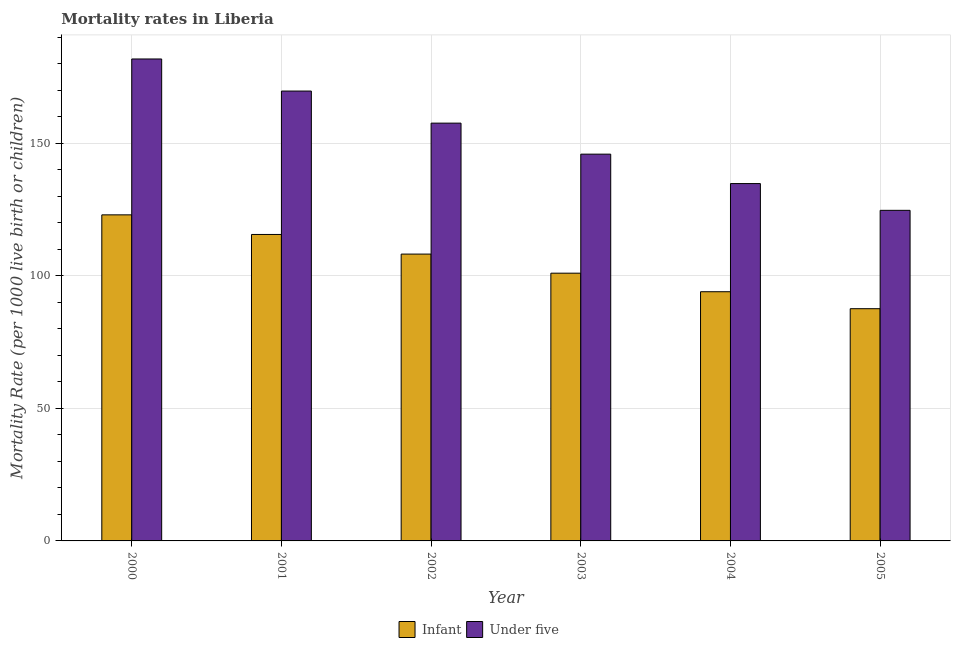How many different coloured bars are there?
Your answer should be very brief. 2. How many groups of bars are there?
Provide a succinct answer. 6. How many bars are there on the 1st tick from the right?
Offer a terse response. 2. What is the label of the 4th group of bars from the left?
Provide a short and direct response. 2003. In how many cases, is the number of bars for a given year not equal to the number of legend labels?
Keep it short and to the point. 0. What is the under-5 mortality rate in 2004?
Keep it short and to the point. 134.8. Across all years, what is the maximum infant mortality rate?
Make the answer very short. 123. Across all years, what is the minimum infant mortality rate?
Make the answer very short. 87.6. In which year was the under-5 mortality rate maximum?
Make the answer very short. 2000. What is the total under-5 mortality rate in the graph?
Provide a succinct answer. 914.5. What is the difference between the under-5 mortality rate in 2002 and that in 2005?
Provide a short and direct response. 32.9. What is the difference between the under-5 mortality rate in 2003 and the infant mortality rate in 2001?
Give a very brief answer. -23.8. What is the average infant mortality rate per year?
Offer a terse response. 104.9. In the year 2001, what is the difference between the under-5 mortality rate and infant mortality rate?
Ensure brevity in your answer.  0. What is the ratio of the under-5 mortality rate in 2000 to that in 2001?
Make the answer very short. 1.07. Is the difference between the infant mortality rate in 2000 and 2003 greater than the difference between the under-5 mortality rate in 2000 and 2003?
Your answer should be very brief. No. What is the difference between the highest and the second highest infant mortality rate?
Your answer should be very brief. 7.4. What is the difference between the highest and the lowest infant mortality rate?
Your response must be concise. 35.4. In how many years, is the under-5 mortality rate greater than the average under-5 mortality rate taken over all years?
Provide a succinct answer. 3. What does the 1st bar from the left in 2002 represents?
Give a very brief answer. Infant. What does the 2nd bar from the right in 2004 represents?
Provide a short and direct response. Infant. How many bars are there?
Ensure brevity in your answer.  12. Are all the bars in the graph horizontal?
Keep it short and to the point. No. How many years are there in the graph?
Provide a short and direct response. 6. What is the difference between two consecutive major ticks on the Y-axis?
Your response must be concise. 50. Are the values on the major ticks of Y-axis written in scientific E-notation?
Your answer should be very brief. No. Does the graph contain any zero values?
Your response must be concise. No. Does the graph contain grids?
Provide a short and direct response. Yes. Where does the legend appear in the graph?
Keep it short and to the point. Bottom center. How are the legend labels stacked?
Keep it short and to the point. Horizontal. What is the title of the graph?
Keep it short and to the point. Mortality rates in Liberia. Does "Commercial bank branches" appear as one of the legend labels in the graph?
Your response must be concise. No. What is the label or title of the Y-axis?
Keep it short and to the point. Mortality Rate (per 1000 live birth or children). What is the Mortality Rate (per 1000 live birth or children) in Infant in 2000?
Ensure brevity in your answer.  123. What is the Mortality Rate (per 1000 live birth or children) of Under five in 2000?
Provide a short and direct response. 181.8. What is the Mortality Rate (per 1000 live birth or children) of Infant in 2001?
Provide a short and direct response. 115.6. What is the Mortality Rate (per 1000 live birth or children) in Under five in 2001?
Offer a very short reply. 169.7. What is the Mortality Rate (per 1000 live birth or children) of Infant in 2002?
Offer a terse response. 108.2. What is the Mortality Rate (per 1000 live birth or children) of Under five in 2002?
Offer a terse response. 157.6. What is the Mortality Rate (per 1000 live birth or children) in Infant in 2003?
Offer a very short reply. 101. What is the Mortality Rate (per 1000 live birth or children) in Under five in 2003?
Offer a terse response. 145.9. What is the Mortality Rate (per 1000 live birth or children) in Infant in 2004?
Offer a very short reply. 94. What is the Mortality Rate (per 1000 live birth or children) in Under five in 2004?
Give a very brief answer. 134.8. What is the Mortality Rate (per 1000 live birth or children) of Infant in 2005?
Provide a short and direct response. 87.6. What is the Mortality Rate (per 1000 live birth or children) in Under five in 2005?
Make the answer very short. 124.7. Across all years, what is the maximum Mortality Rate (per 1000 live birth or children) in Infant?
Your response must be concise. 123. Across all years, what is the maximum Mortality Rate (per 1000 live birth or children) of Under five?
Your answer should be very brief. 181.8. Across all years, what is the minimum Mortality Rate (per 1000 live birth or children) in Infant?
Offer a very short reply. 87.6. Across all years, what is the minimum Mortality Rate (per 1000 live birth or children) in Under five?
Offer a very short reply. 124.7. What is the total Mortality Rate (per 1000 live birth or children) in Infant in the graph?
Offer a terse response. 629.4. What is the total Mortality Rate (per 1000 live birth or children) of Under five in the graph?
Give a very brief answer. 914.5. What is the difference between the Mortality Rate (per 1000 live birth or children) in Infant in 2000 and that in 2001?
Offer a very short reply. 7.4. What is the difference between the Mortality Rate (per 1000 live birth or children) in Under five in 2000 and that in 2001?
Provide a short and direct response. 12.1. What is the difference between the Mortality Rate (per 1000 live birth or children) in Under five in 2000 and that in 2002?
Your answer should be compact. 24.2. What is the difference between the Mortality Rate (per 1000 live birth or children) of Under five in 2000 and that in 2003?
Your answer should be compact. 35.9. What is the difference between the Mortality Rate (per 1000 live birth or children) in Infant in 2000 and that in 2004?
Your answer should be very brief. 29. What is the difference between the Mortality Rate (per 1000 live birth or children) of Under five in 2000 and that in 2004?
Your response must be concise. 47. What is the difference between the Mortality Rate (per 1000 live birth or children) in Infant in 2000 and that in 2005?
Make the answer very short. 35.4. What is the difference between the Mortality Rate (per 1000 live birth or children) in Under five in 2000 and that in 2005?
Your response must be concise. 57.1. What is the difference between the Mortality Rate (per 1000 live birth or children) in Infant in 2001 and that in 2002?
Your answer should be very brief. 7.4. What is the difference between the Mortality Rate (per 1000 live birth or children) of Under five in 2001 and that in 2002?
Your answer should be very brief. 12.1. What is the difference between the Mortality Rate (per 1000 live birth or children) of Under five in 2001 and that in 2003?
Ensure brevity in your answer.  23.8. What is the difference between the Mortality Rate (per 1000 live birth or children) in Infant in 2001 and that in 2004?
Keep it short and to the point. 21.6. What is the difference between the Mortality Rate (per 1000 live birth or children) of Under five in 2001 and that in 2004?
Provide a succinct answer. 34.9. What is the difference between the Mortality Rate (per 1000 live birth or children) of Under five in 2001 and that in 2005?
Offer a very short reply. 45. What is the difference between the Mortality Rate (per 1000 live birth or children) in Infant in 2002 and that in 2003?
Your response must be concise. 7.2. What is the difference between the Mortality Rate (per 1000 live birth or children) of Under five in 2002 and that in 2004?
Offer a terse response. 22.8. What is the difference between the Mortality Rate (per 1000 live birth or children) of Infant in 2002 and that in 2005?
Your answer should be very brief. 20.6. What is the difference between the Mortality Rate (per 1000 live birth or children) in Under five in 2002 and that in 2005?
Ensure brevity in your answer.  32.9. What is the difference between the Mortality Rate (per 1000 live birth or children) of Infant in 2003 and that in 2004?
Your answer should be compact. 7. What is the difference between the Mortality Rate (per 1000 live birth or children) of Under five in 2003 and that in 2004?
Give a very brief answer. 11.1. What is the difference between the Mortality Rate (per 1000 live birth or children) of Under five in 2003 and that in 2005?
Your answer should be compact. 21.2. What is the difference between the Mortality Rate (per 1000 live birth or children) of Infant in 2000 and the Mortality Rate (per 1000 live birth or children) of Under five in 2001?
Make the answer very short. -46.7. What is the difference between the Mortality Rate (per 1000 live birth or children) in Infant in 2000 and the Mortality Rate (per 1000 live birth or children) in Under five in 2002?
Your answer should be compact. -34.6. What is the difference between the Mortality Rate (per 1000 live birth or children) in Infant in 2000 and the Mortality Rate (per 1000 live birth or children) in Under five in 2003?
Provide a short and direct response. -22.9. What is the difference between the Mortality Rate (per 1000 live birth or children) of Infant in 2000 and the Mortality Rate (per 1000 live birth or children) of Under five in 2005?
Your answer should be compact. -1.7. What is the difference between the Mortality Rate (per 1000 live birth or children) in Infant in 2001 and the Mortality Rate (per 1000 live birth or children) in Under five in 2002?
Ensure brevity in your answer.  -42. What is the difference between the Mortality Rate (per 1000 live birth or children) of Infant in 2001 and the Mortality Rate (per 1000 live birth or children) of Under five in 2003?
Keep it short and to the point. -30.3. What is the difference between the Mortality Rate (per 1000 live birth or children) in Infant in 2001 and the Mortality Rate (per 1000 live birth or children) in Under five in 2004?
Your answer should be compact. -19.2. What is the difference between the Mortality Rate (per 1000 live birth or children) of Infant in 2002 and the Mortality Rate (per 1000 live birth or children) of Under five in 2003?
Offer a terse response. -37.7. What is the difference between the Mortality Rate (per 1000 live birth or children) in Infant in 2002 and the Mortality Rate (per 1000 live birth or children) in Under five in 2004?
Provide a succinct answer. -26.6. What is the difference between the Mortality Rate (per 1000 live birth or children) in Infant in 2002 and the Mortality Rate (per 1000 live birth or children) in Under five in 2005?
Provide a succinct answer. -16.5. What is the difference between the Mortality Rate (per 1000 live birth or children) in Infant in 2003 and the Mortality Rate (per 1000 live birth or children) in Under five in 2004?
Keep it short and to the point. -33.8. What is the difference between the Mortality Rate (per 1000 live birth or children) of Infant in 2003 and the Mortality Rate (per 1000 live birth or children) of Under five in 2005?
Your answer should be very brief. -23.7. What is the difference between the Mortality Rate (per 1000 live birth or children) in Infant in 2004 and the Mortality Rate (per 1000 live birth or children) in Under five in 2005?
Offer a terse response. -30.7. What is the average Mortality Rate (per 1000 live birth or children) in Infant per year?
Give a very brief answer. 104.9. What is the average Mortality Rate (per 1000 live birth or children) of Under five per year?
Offer a terse response. 152.42. In the year 2000, what is the difference between the Mortality Rate (per 1000 live birth or children) in Infant and Mortality Rate (per 1000 live birth or children) in Under five?
Provide a short and direct response. -58.8. In the year 2001, what is the difference between the Mortality Rate (per 1000 live birth or children) in Infant and Mortality Rate (per 1000 live birth or children) in Under five?
Keep it short and to the point. -54.1. In the year 2002, what is the difference between the Mortality Rate (per 1000 live birth or children) in Infant and Mortality Rate (per 1000 live birth or children) in Under five?
Offer a very short reply. -49.4. In the year 2003, what is the difference between the Mortality Rate (per 1000 live birth or children) in Infant and Mortality Rate (per 1000 live birth or children) in Under five?
Ensure brevity in your answer.  -44.9. In the year 2004, what is the difference between the Mortality Rate (per 1000 live birth or children) of Infant and Mortality Rate (per 1000 live birth or children) of Under five?
Make the answer very short. -40.8. In the year 2005, what is the difference between the Mortality Rate (per 1000 live birth or children) in Infant and Mortality Rate (per 1000 live birth or children) in Under five?
Your answer should be compact. -37.1. What is the ratio of the Mortality Rate (per 1000 live birth or children) in Infant in 2000 to that in 2001?
Give a very brief answer. 1.06. What is the ratio of the Mortality Rate (per 1000 live birth or children) of Under five in 2000 to that in 2001?
Your answer should be very brief. 1.07. What is the ratio of the Mortality Rate (per 1000 live birth or children) in Infant in 2000 to that in 2002?
Keep it short and to the point. 1.14. What is the ratio of the Mortality Rate (per 1000 live birth or children) of Under five in 2000 to that in 2002?
Make the answer very short. 1.15. What is the ratio of the Mortality Rate (per 1000 live birth or children) of Infant in 2000 to that in 2003?
Your response must be concise. 1.22. What is the ratio of the Mortality Rate (per 1000 live birth or children) of Under five in 2000 to that in 2003?
Provide a succinct answer. 1.25. What is the ratio of the Mortality Rate (per 1000 live birth or children) of Infant in 2000 to that in 2004?
Keep it short and to the point. 1.31. What is the ratio of the Mortality Rate (per 1000 live birth or children) in Under five in 2000 to that in 2004?
Keep it short and to the point. 1.35. What is the ratio of the Mortality Rate (per 1000 live birth or children) of Infant in 2000 to that in 2005?
Provide a succinct answer. 1.4. What is the ratio of the Mortality Rate (per 1000 live birth or children) of Under five in 2000 to that in 2005?
Your answer should be very brief. 1.46. What is the ratio of the Mortality Rate (per 1000 live birth or children) in Infant in 2001 to that in 2002?
Provide a short and direct response. 1.07. What is the ratio of the Mortality Rate (per 1000 live birth or children) of Under five in 2001 to that in 2002?
Provide a succinct answer. 1.08. What is the ratio of the Mortality Rate (per 1000 live birth or children) in Infant in 2001 to that in 2003?
Your answer should be very brief. 1.14. What is the ratio of the Mortality Rate (per 1000 live birth or children) in Under five in 2001 to that in 2003?
Offer a terse response. 1.16. What is the ratio of the Mortality Rate (per 1000 live birth or children) of Infant in 2001 to that in 2004?
Your response must be concise. 1.23. What is the ratio of the Mortality Rate (per 1000 live birth or children) of Under five in 2001 to that in 2004?
Provide a short and direct response. 1.26. What is the ratio of the Mortality Rate (per 1000 live birth or children) of Infant in 2001 to that in 2005?
Ensure brevity in your answer.  1.32. What is the ratio of the Mortality Rate (per 1000 live birth or children) of Under five in 2001 to that in 2005?
Provide a short and direct response. 1.36. What is the ratio of the Mortality Rate (per 1000 live birth or children) of Infant in 2002 to that in 2003?
Offer a terse response. 1.07. What is the ratio of the Mortality Rate (per 1000 live birth or children) of Under five in 2002 to that in 2003?
Offer a terse response. 1.08. What is the ratio of the Mortality Rate (per 1000 live birth or children) of Infant in 2002 to that in 2004?
Your response must be concise. 1.15. What is the ratio of the Mortality Rate (per 1000 live birth or children) in Under five in 2002 to that in 2004?
Your response must be concise. 1.17. What is the ratio of the Mortality Rate (per 1000 live birth or children) of Infant in 2002 to that in 2005?
Provide a succinct answer. 1.24. What is the ratio of the Mortality Rate (per 1000 live birth or children) in Under five in 2002 to that in 2005?
Your response must be concise. 1.26. What is the ratio of the Mortality Rate (per 1000 live birth or children) in Infant in 2003 to that in 2004?
Provide a short and direct response. 1.07. What is the ratio of the Mortality Rate (per 1000 live birth or children) in Under five in 2003 to that in 2004?
Provide a short and direct response. 1.08. What is the ratio of the Mortality Rate (per 1000 live birth or children) of Infant in 2003 to that in 2005?
Offer a terse response. 1.15. What is the ratio of the Mortality Rate (per 1000 live birth or children) of Under five in 2003 to that in 2005?
Your answer should be compact. 1.17. What is the ratio of the Mortality Rate (per 1000 live birth or children) in Infant in 2004 to that in 2005?
Offer a very short reply. 1.07. What is the ratio of the Mortality Rate (per 1000 live birth or children) of Under five in 2004 to that in 2005?
Your response must be concise. 1.08. What is the difference between the highest and the second highest Mortality Rate (per 1000 live birth or children) in Infant?
Give a very brief answer. 7.4. What is the difference between the highest and the second highest Mortality Rate (per 1000 live birth or children) of Under five?
Provide a short and direct response. 12.1. What is the difference between the highest and the lowest Mortality Rate (per 1000 live birth or children) of Infant?
Provide a succinct answer. 35.4. What is the difference between the highest and the lowest Mortality Rate (per 1000 live birth or children) in Under five?
Provide a short and direct response. 57.1. 